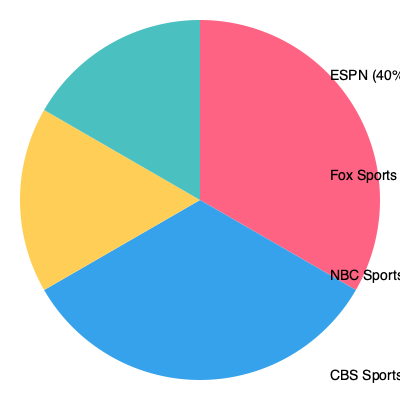Based on the pie chart showing market share of sports broadcasting networks, what percentage of the market would be controlled if Fox Sports and NBC Sports merged their operations? To determine the combined market share of Fox Sports and NBC Sports if they merged, we need to:

1. Identify the individual market shares:
   - Fox Sports: 30%
   - NBC Sports: 20%

2. Add these percentages together:
   $30\% + 20\% = 50\%$

3. Verify the result:
   - The total should be less than 100% (the entire market)
   - 50% is indeed less than 100%, so our calculation is plausible

4. Consider the implications:
   - This merger would create a entity with a larger market share than the current leader, ESPN (40%)
   - It would significantly alter the competitive landscape in sports broadcasting

Therefore, if Fox Sports and NBC Sports merged, they would control 50% of the sports broadcasting market share.
Answer: 50% 